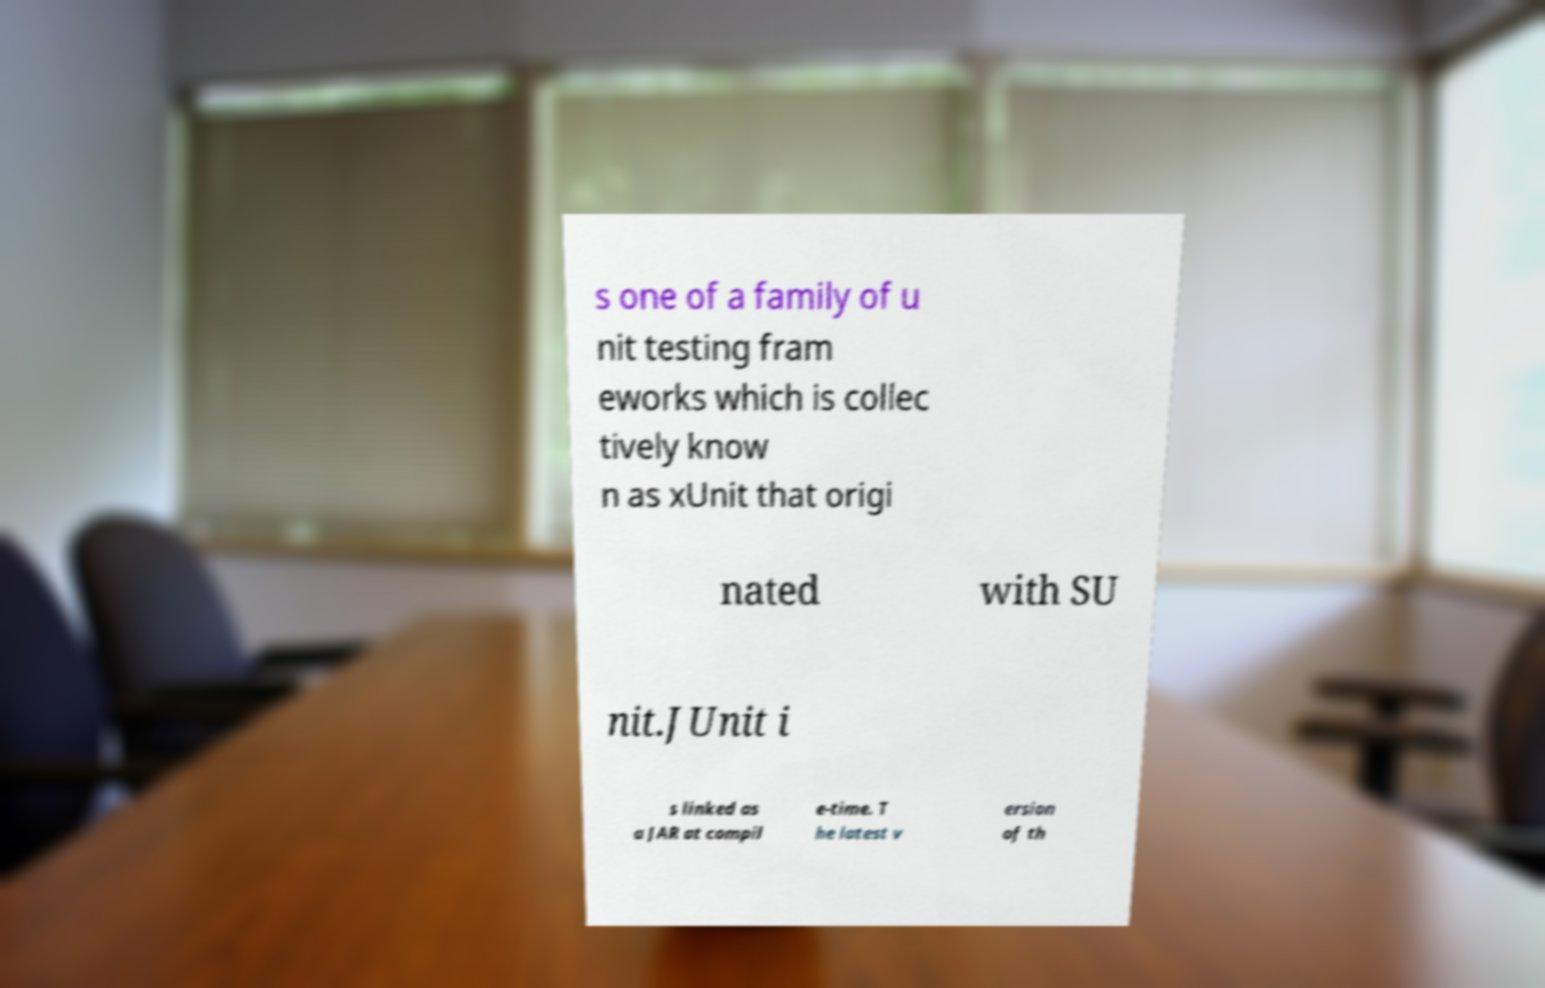What messages or text are displayed in this image? I need them in a readable, typed format. s one of a family of u nit testing fram eworks which is collec tively know n as xUnit that origi nated with SU nit.JUnit i s linked as a JAR at compil e-time. T he latest v ersion of th 